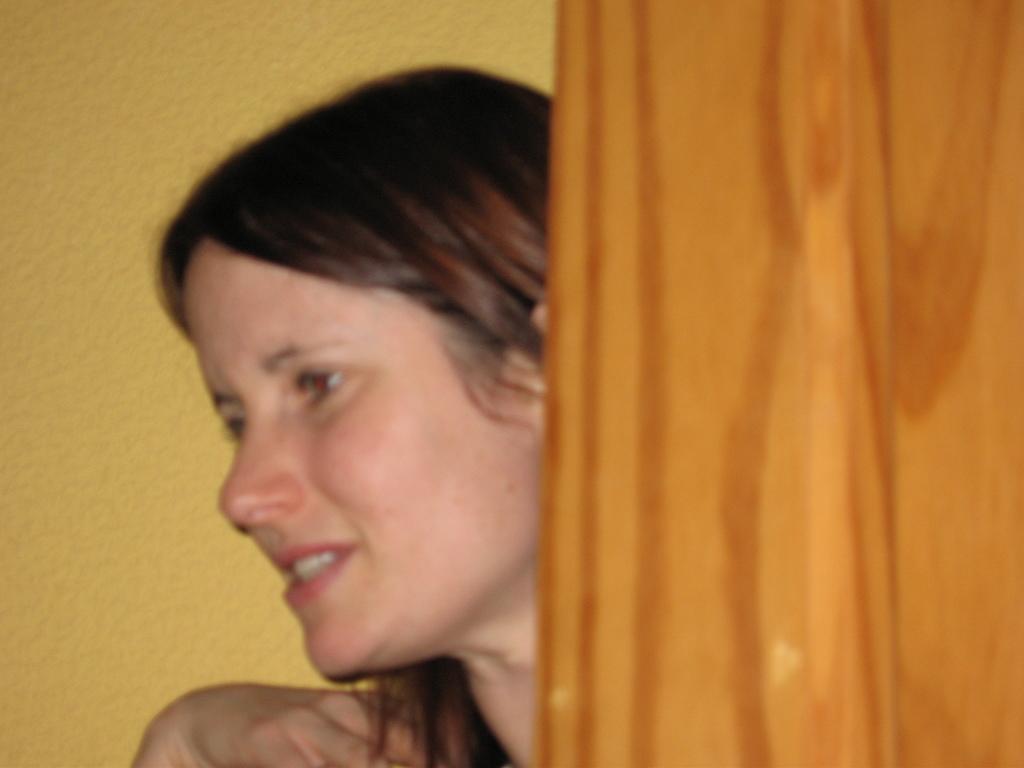How would you summarize this image in a sentence or two? in this image a lady is standing. Here there is a door. In the background there is yellow wall. 